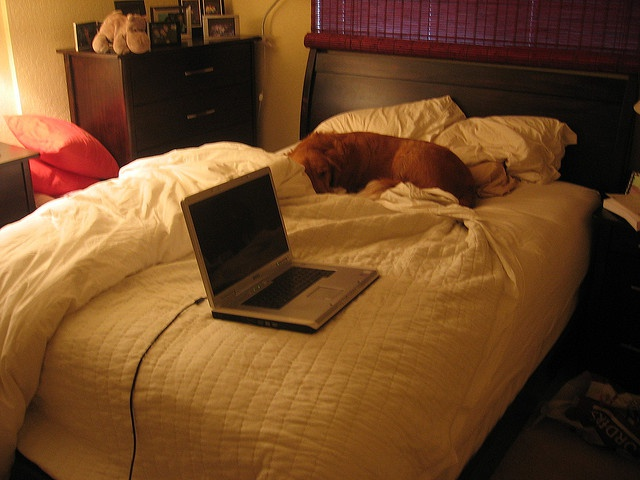Describe the objects in this image and their specific colors. I can see bed in orange, olive, maroon, and black tones, laptop in orange, black, maroon, and brown tones, and dog in orange, maroon, black, and brown tones in this image. 